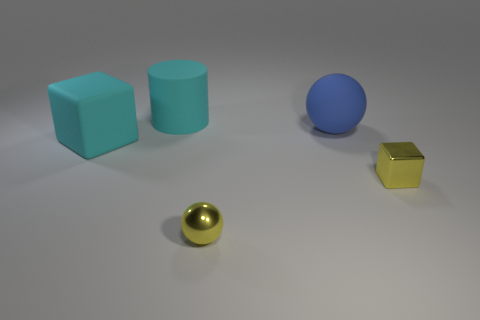Is the number of rubber cubes right of the large rubber sphere greater than the number of big balls?
Provide a succinct answer. No. Are there any large blue spheres?
Your answer should be compact. Yes. How many rubber objects are the same size as the cyan matte cylinder?
Make the answer very short. 2. Are there more tiny metallic cubes that are to the left of the yellow sphere than yellow things in front of the large blue matte thing?
Offer a very short reply. No. What material is the object that is the same size as the yellow sphere?
Your response must be concise. Metal. The large blue matte object has what shape?
Make the answer very short. Sphere. What number of yellow things are small objects or big rubber cylinders?
Give a very brief answer. 2. There is a yellow object that is the same material as the tiny cube; what size is it?
Provide a short and direct response. Small. Does the big cyan object on the left side of the big cyan matte cylinder have the same material as the yellow object to the right of the yellow metallic sphere?
Make the answer very short. No. How many cylinders are big cyan objects or rubber objects?
Your response must be concise. 1. 